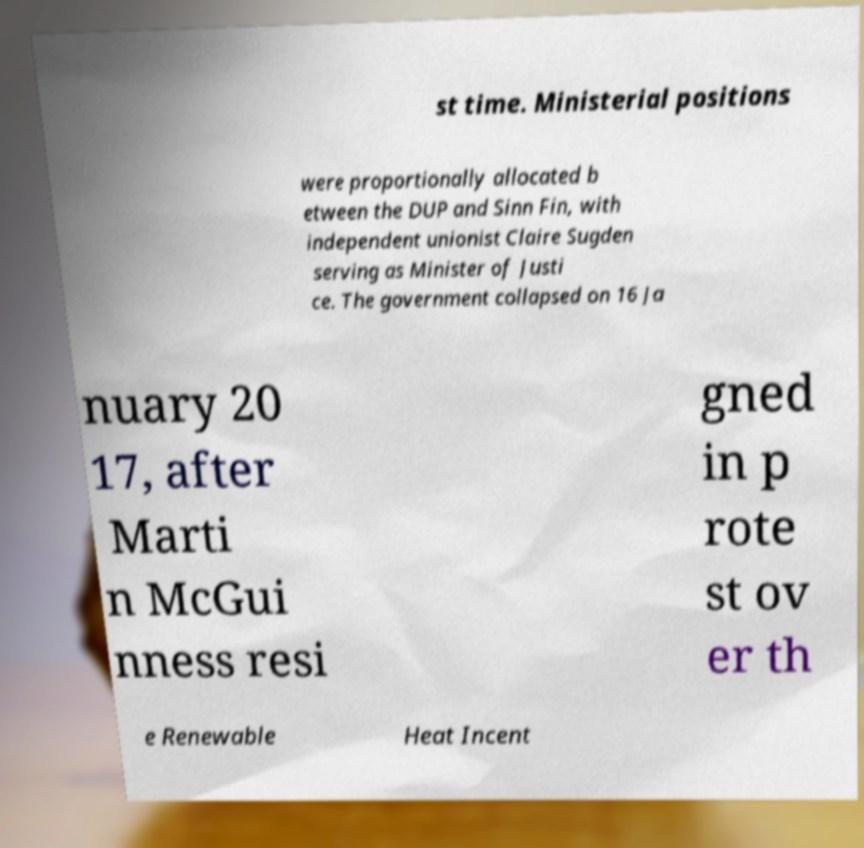Could you extract and type out the text from this image? st time. Ministerial positions were proportionally allocated b etween the DUP and Sinn Fin, with independent unionist Claire Sugden serving as Minister of Justi ce. The government collapsed on 16 Ja nuary 20 17, after Marti n McGui nness resi gned in p rote st ov er th e Renewable Heat Incent 